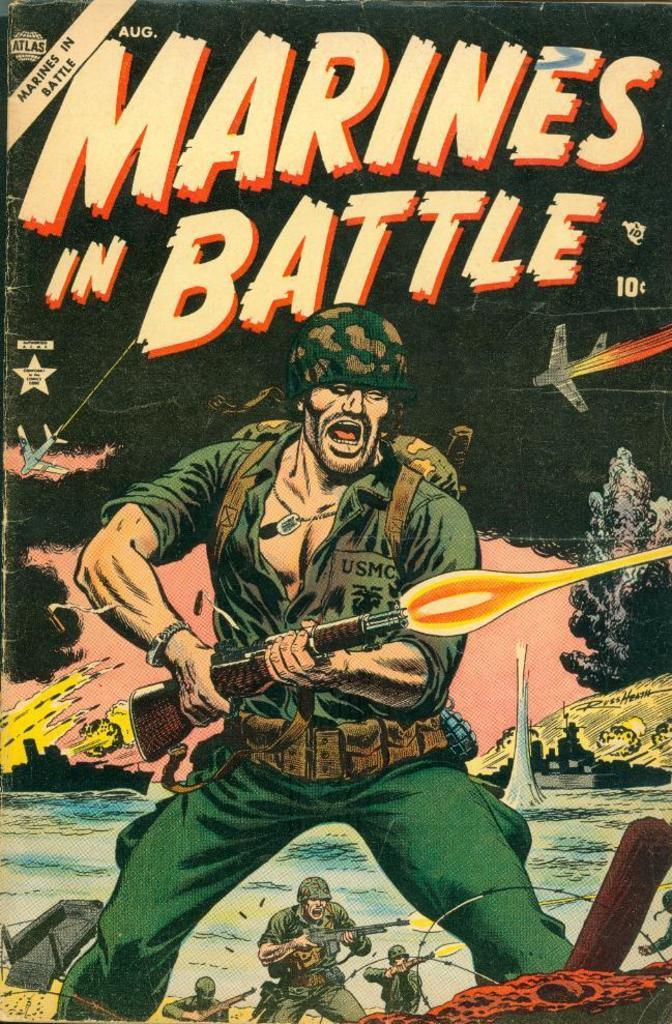What object can be seen in the image? There is a book in the image. What type of tooth is visible in the image? There is no tooth present in the image; it only features a book. Can you tell me how many bees are buzzing around the book in the image? There are no bees present in the image; it only features a book. 